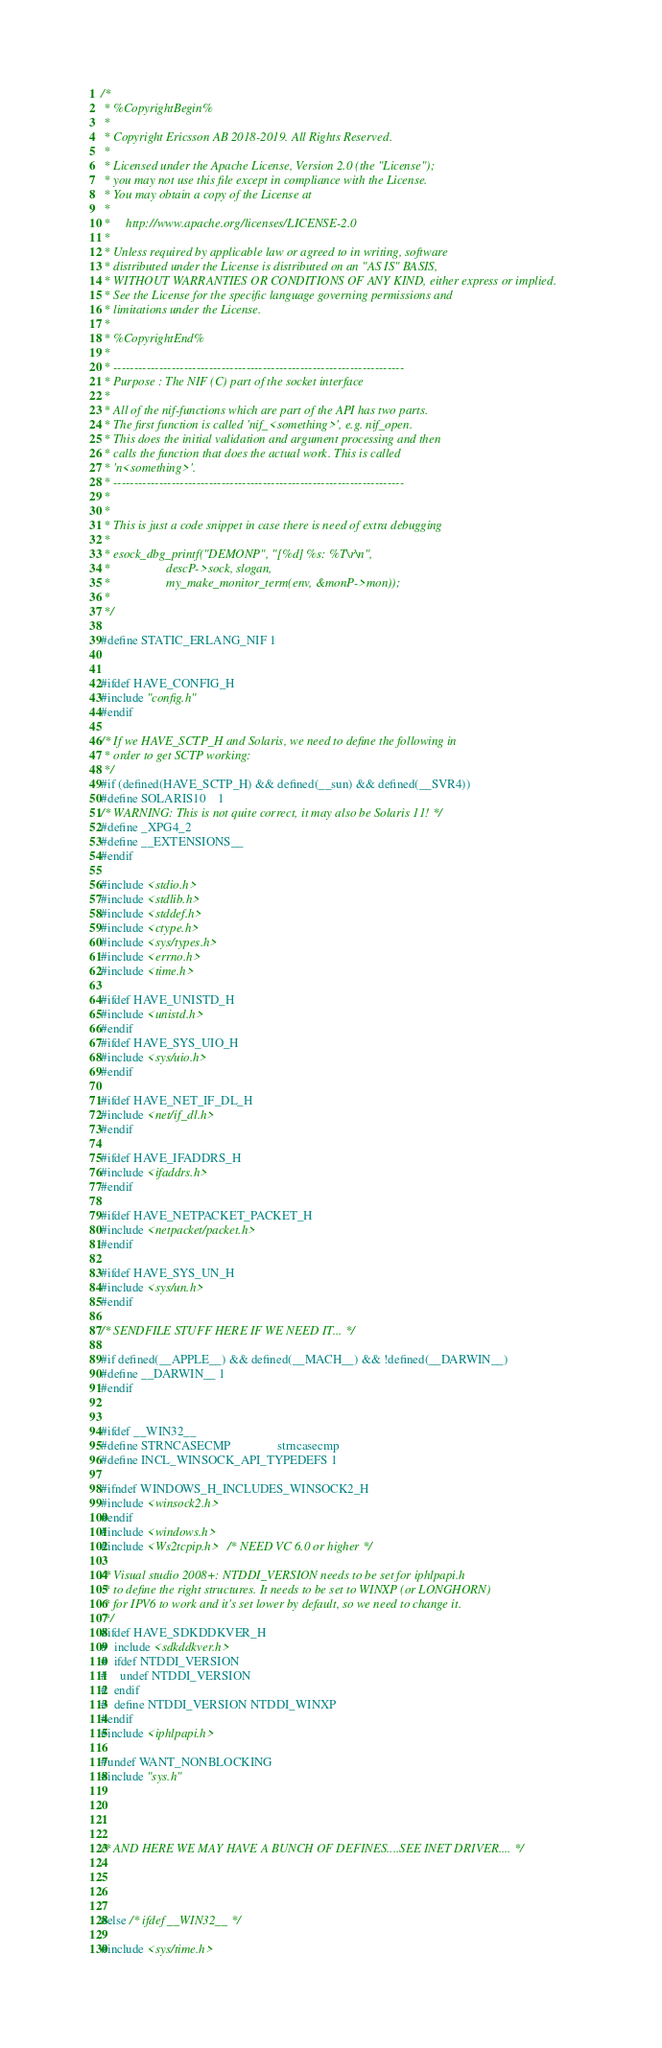Convert code to text. <code><loc_0><loc_0><loc_500><loc_500><_C_>/*
 * %CopyrightBegin%
 *
 * Copyright Ericsson AB 2018-2019. All Rights Reserved.
 *
 * Licensed under the Apache License, Version 2.0 (the "License");
 * you may not use this file except in compliance with the License.
 * You may obtain a copy of the License at
 *
 *     http://www.apache.org/licenses/LICENSE-2.0
 *
 * Unless required by applicable law or agreed to in writing, software
 * distributed under the License is distributed on an "AS IS" BASIS,
 * WITHOUT WARRANTIES OR CONDITIONS OF ANY KIND, either express or implied.
 * See the License for the specific language governing permissions and
 * limitations under the License.
 *
 * %CopyrightEnd%
 *
 * ----------------------------------------------------------------------
 * Purpose : The NIF (C) part of the socket interface
 *
 * All of the nif-functions which are part of the API has two parts.
 * The first function is called 'nif_<something>', e.g. nif_open.
 * This does the initial validation and argument processing and then 
 * calls the function that does the actual work. This is called
 * 'n<something>'.
 * ----------------------------------------------------------------------
 *
 *
 * This is just a code snippet in case there is need of extra debugging
 *
 * esock_dbg_printf("DEMONP", "[%d] %s: %T\r\n",
 *                  descP->sock, slogan,
 *                  my_make_monitor_term(env, &monP->mon));
 *
 */

#define STATIC_ERLANG_NIF 1


#ifdef HAVE_CONFIG_H
#include "config.h"
#endif

/* If we HAVE_SCTP_H and Solaris, we need to define the following in
 * order to get SCTP working:
 */
#if (defined(HAVE_SCTP_H) && defined(__sun) && defined(__SVR4))
#define SOLARIS10    1
/* WARNING: This is not quite correct, it may also be Solaris 11! */
#define _XPG4_2
#define __EXTENSIONS__
#endif

#include <stdio.h>
#include <stdlib.h>
#include <stddef.h>
#include <ctype.h>
#include <sys/types.h>
#include <errno.h>
#include <time.h>

#ifdef HAVE_UNISTD_H
#include <unistd.h>
#endif
#ifdef HAVE_SYS_UIO_H
#include <sys/uio.h>
#endif

#ifdef HAVE_NET_IF_DL_H
#include <net/if_dl.h>
#endif

#ifdef HAVE_IFADDRS_H
#include <ifaddrs.h>
#endif

#ifdef HAVE_NETPACKET_PACKET_H
#include <netpacket/packet.h>
#endif

#ifdef HAVE_SYS_UN_H
#include <sys/un.h>
#endif

/* SENDFILE STUFF HERE IF WE NEED IT... */

#if defined(__APPLE__) && defined(__MACH__) && !defined(__DARWIN__)
#define __DARWIN__ 1
#endif


#ifdef __WIN32__
#define STRNCASECMP               strncasecmp
#define INCL_WINSOCK_API_TYPEDEFS 1

#ifndef WINDOWS_H_INCLUDES_WINSOCK2_H
#include <winsock2.h>
#endif
#include <windows.h>
#include <Ws2tcpip.h>   /* NEED VC 6.0 or higher */

/* Visual studio 2008+: NTDDI_VERSION needs to be set for iphlpapi.h
 * to define the right structures. It needs to be set to WINXP (or LONGHORN)
 * for IPV6 to work and it's set lower by default, so we need to change it.
 */
#ifdef HAVE_SDKDDKVER_H
#  include <sdkddkver.h>
#  ifdef NTDDI_VERSION
#    undef NTDDI_VERSION
#  endif
#  define NTDDI_VERSION NTDDI_WINXP
#endif
#include <iphlpapi.h>

#undef WANT_NONBLOCKING
#include "sys.h"




/* AND HERE WE MAY HAVE A BUNCH OF DEFINES....SEE INET DRIVER.... */




#else /* ifdef __WIN32__ */

#include <sys/time.h></code> 